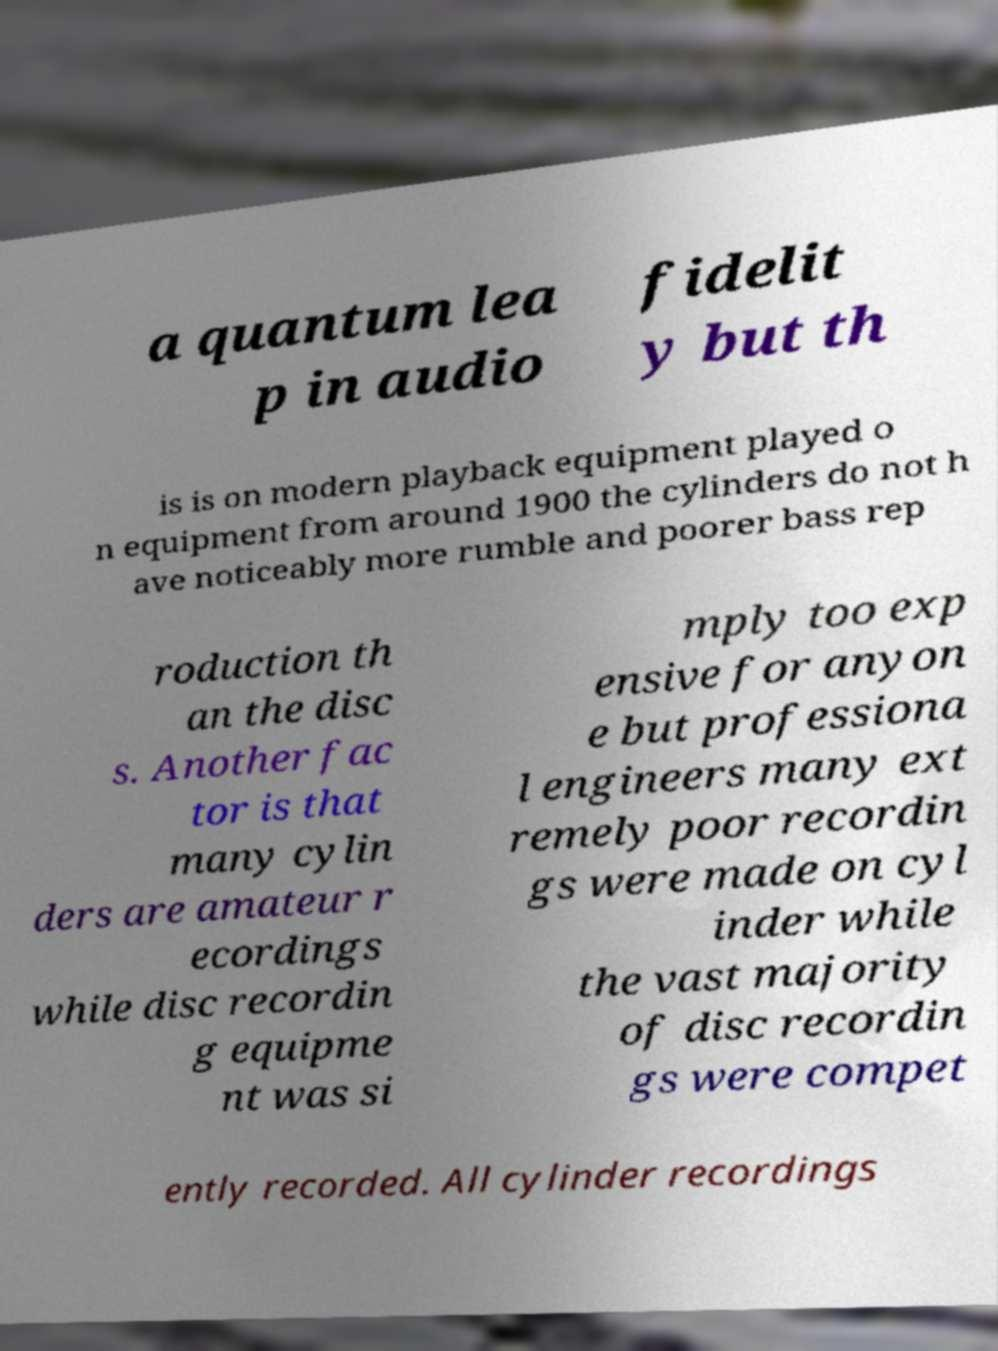I need the written content from this picture converted into text. Can you do that? a quantum lea p in audio fidelit y but th is is on modern playback equipment played o n equipment from around 1900 the cylinders do not h ave noticeably more rumble and poorer bass rep roduction th an the disc s. Another fac tor is that many cylin ders are amateur r ecordings while disc recordin g equipme nt was si mply too exp ensive for anyon e but professiona l engineers many ext remely poor recordin gs were made on cyl inder while the vast majority of disc recordin gs were compet ently recorded. All cylinder recordings 